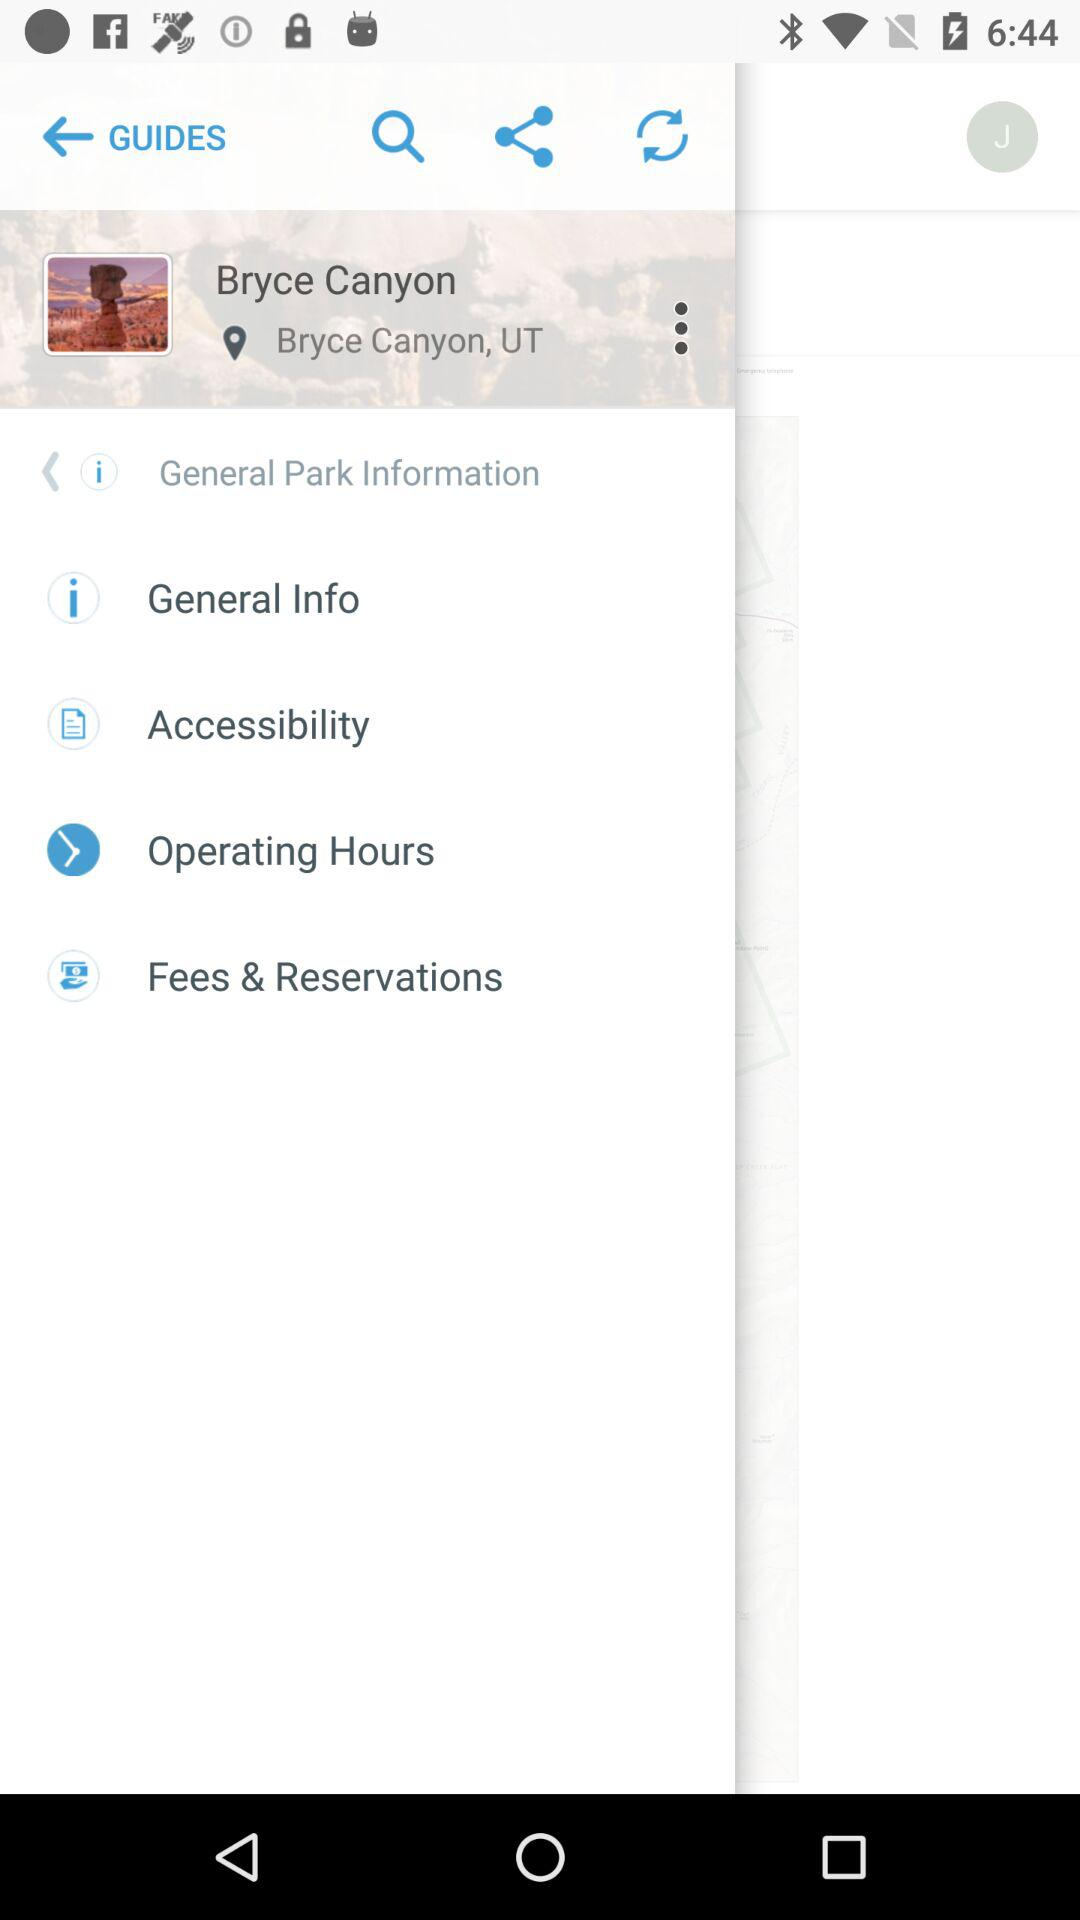In what state is the park situated? The park is situated in Utah. 